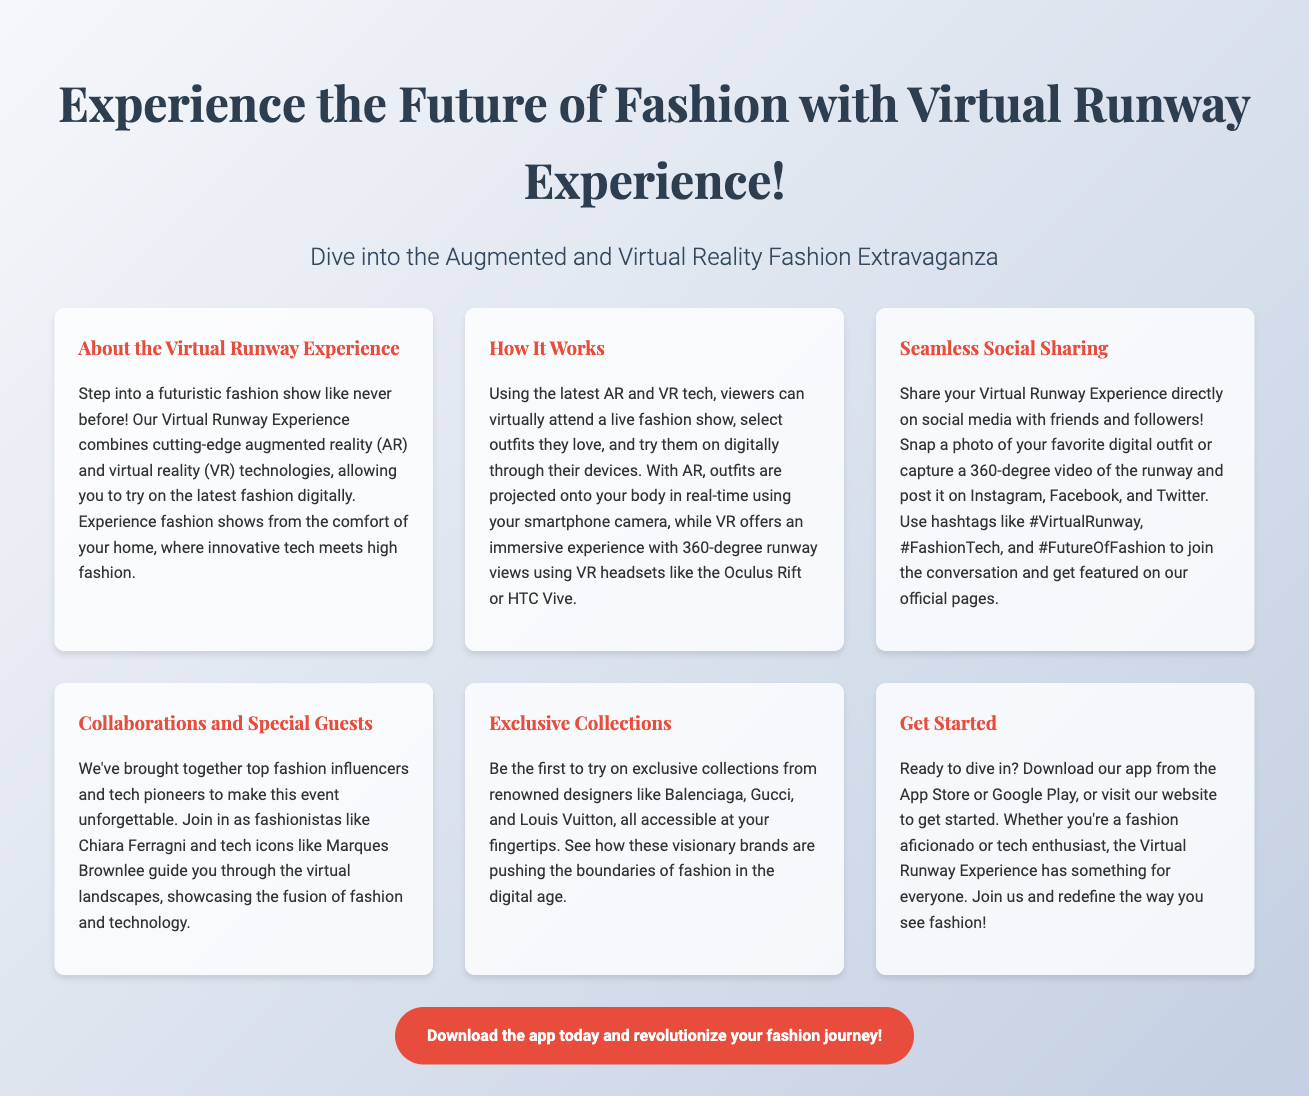What is the main theme of the advertisement? The document promotes the concept of a virtual fashion show using AR and VR technologies.
Answer: Virtual Runway Experience Which technologies are used in the Virtual Runway Experience? The advertisement mentions the use of augmented reality (AR) and virtual reality (VR) technologies.
Answer: AR and VR Who are some of the influencers mentioned for collaborations? The document lists fashionistas and tech icons like Chiara Ferragni and Marques Brownlee.
Answer: Chiara Ferragni, Marques Brownlee What types of devices can viewers use for this experience? Viewers can use smartphones for AR and VR headsets like Oculus Rift or HTC Vive for an immersive experience.
Answer: Smartphones, Oculus Rift, HTC Vive How can participants share their experiences on social media? The document encourages participants to share photos and videos on platforms like Instagram, Facebook, and Twitter using specific hashtags.
Answer: Social media How can users get started with the Virtual Runway Experience? Users are instructed to download an app from the App Store or Google Play, or visit the website.
Answer: App Store, Google Play What fashion brands are featured in the exclusive collections? The advertisement highlights renowned designers like Balenciaga, Gucci, and Louis Vuitton.
Answer: Balenciaga, Gucci, Louis Vuitton What kind of visuals does the Virtual Runway Experience offer during fashion shows? The description mentions 360-degree runway views during the shows.
Answer: 360-degree runway views What is the call to action in the advertisement? The advertisement encourages users to download the app and revolutionize their fashion journey.
Answer: Download the app today 